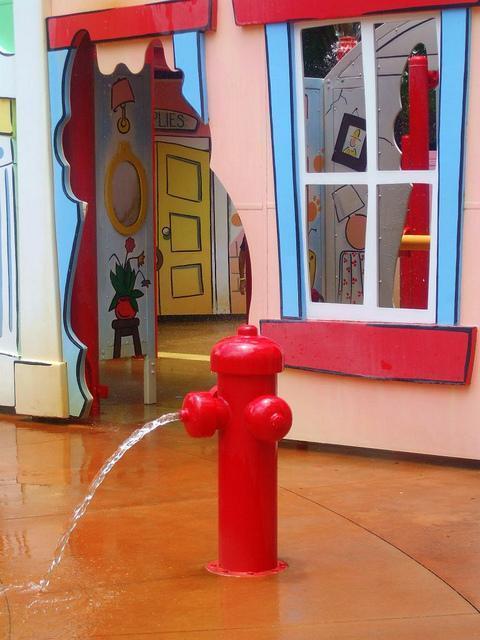How many elephants are facing the camera?
Give a very brief answer. 0. 